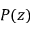Convert formula to latex. <formula><loc_0><loc_0><loc_500><loc_500>P ( z )</formula> 